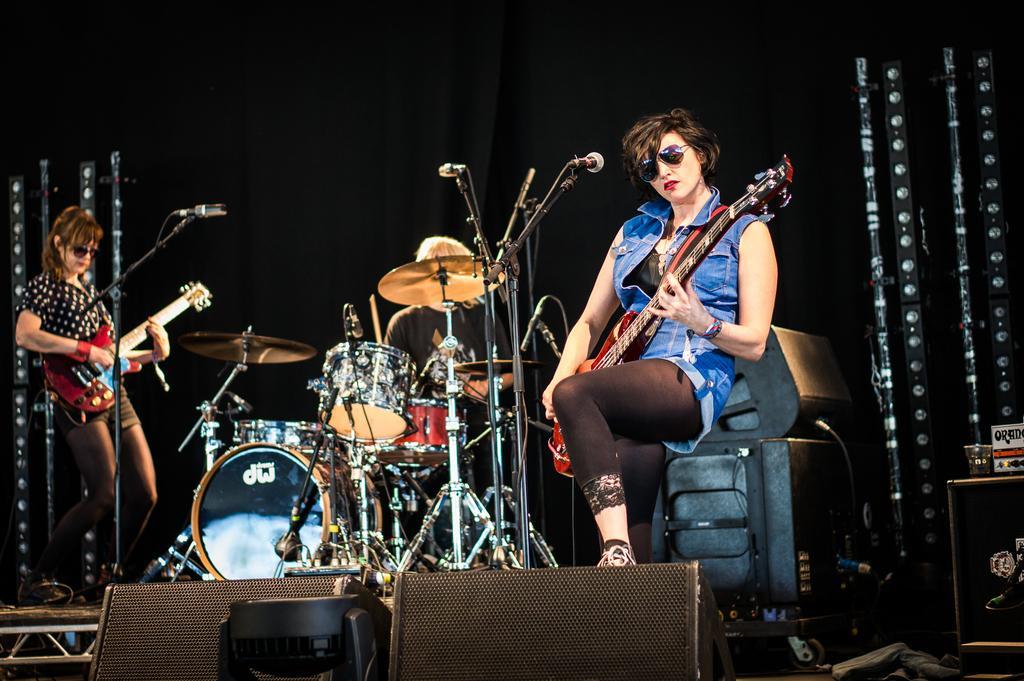In one or two sentences, can you explain what this image depicts? These two persons sitting and playing musical instruments and this person standing and holding guitar. We can see microphones with stand. On the background we can see curtain. 